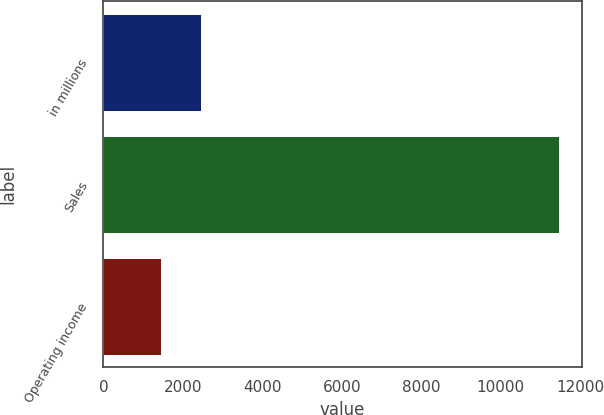<chart> <loc_0><loc_0><loc_500><loc_500><bar_chart><fcel>in millions<fcel>Sales<fcel>Operating income<nl><fcel>2444.8<fcel>11470<fcel>1442<nl></chart> 